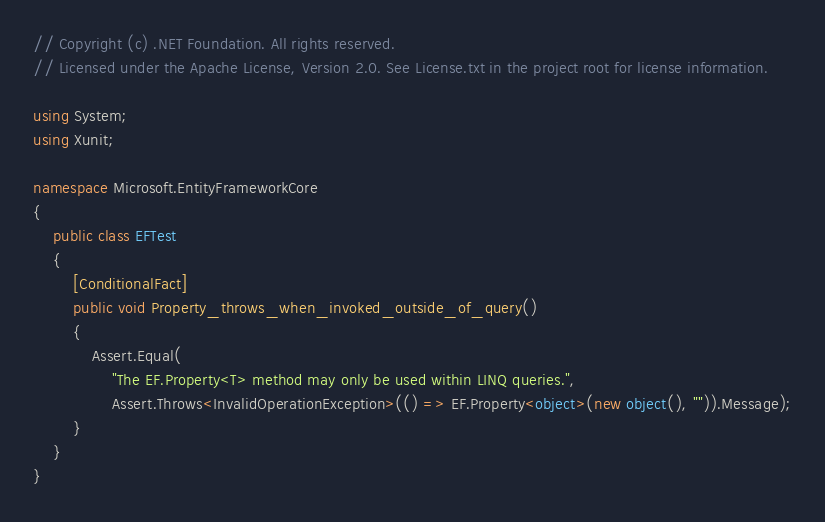Convert code to text. <code><loc_0><loc_0><loc_500><loc_500><_C#_>// Copyright (c) .NET Foundation. All rights reserved.
// Licensed under the Apache License, Version 2.0. See License.txt in the project root for license information.

using System;
using Xunit;

namespace Microsoft.EntityFrameworkCore
{
    public class EFTest
    {
        [ConditionalFact]
        public void Property_throws_when_invoked_outside_of_query()
        {
            Assert.Equal(
                "The EF.Property<T> method may only be used within LINQ queries.",
                Assert.Throws<InvalidOperationException>(() => EF.Property<object>(new object(), "")).Message);
        }
    }
}
</code> 